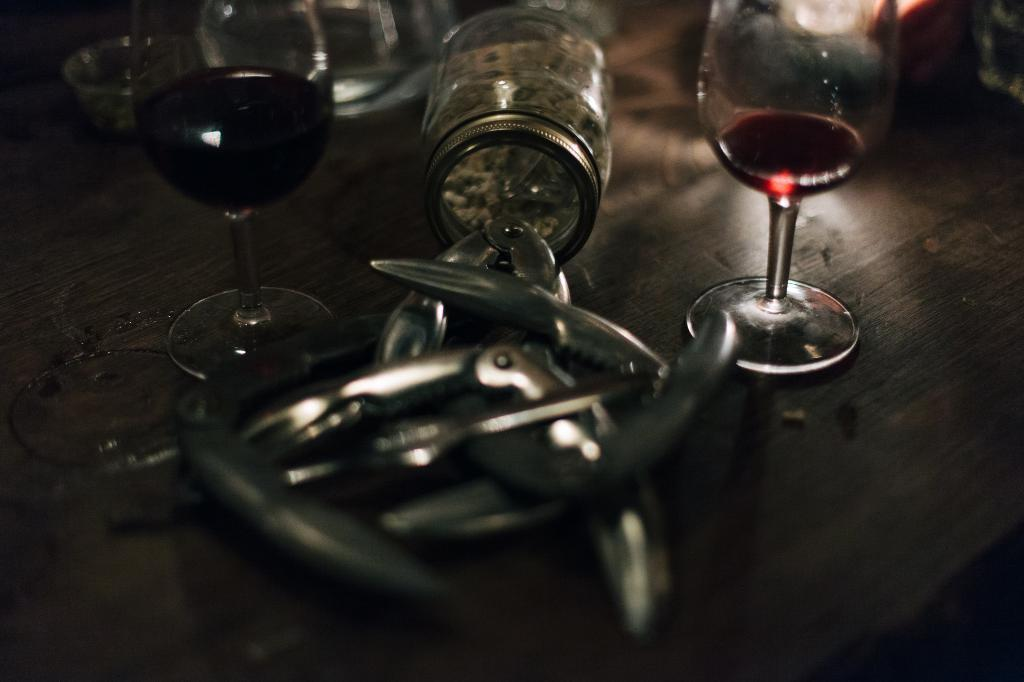How many glasses of drinks are visible in the image? There are two glasses of drinks in the image. What other type of container is present in the image? There is a glass jar in the image. Can you describe the surface on which the glasses and jar are placed? The glasses and jar are placed on a wooden surface. What type of force is being applied to the cabbage in the image? There is no cabbage present in the image, so it is not possible to determine what type of force might be applied to it. 